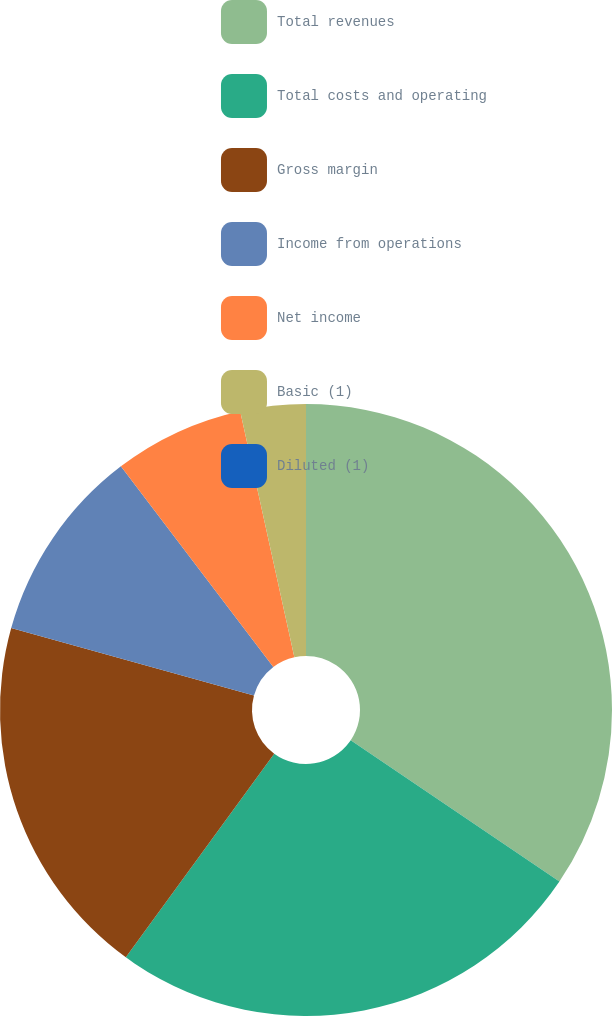Convert chart. <chart><loc_0><loc_0><loc_500><loc_500><pie_chart><fcel>Total revenues<fcel>Total costs and operating<fcel>Gross margin<fcel>Income from operations<fcel>Net income<fcel>Basic (1)<fcel>Diluted (1)<nl><fcel>34.47%<fcel>25.55%<fcel>19.3%<fcel>10.34%<fcel>6.89%<fcel>3.45%<fcel>0.0%<nl></chart> 